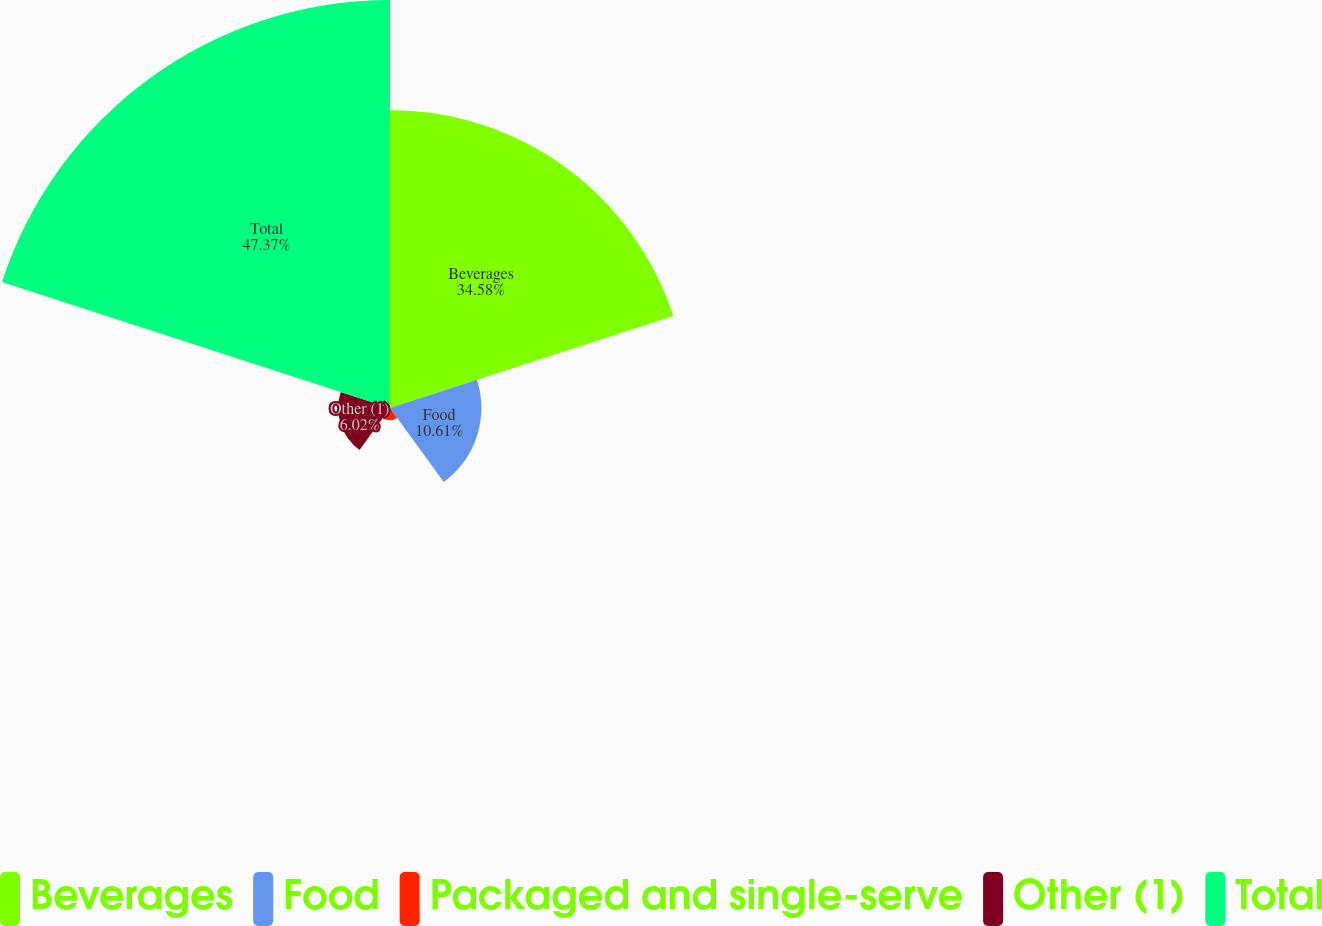Convert chart to OTSL. <chart><loc_0><loc_0><loc_500><loc_500><pie_chart><fcel>Beverages<fcel>Food<fcel>Packaged and single-serve<fcel>Other (1)<fcel>Total<nl><fcel>34.58%<fcel>10.61%<fcel>1.42%<fcel>6.02%<fcel>47.37%<nl></chart> 